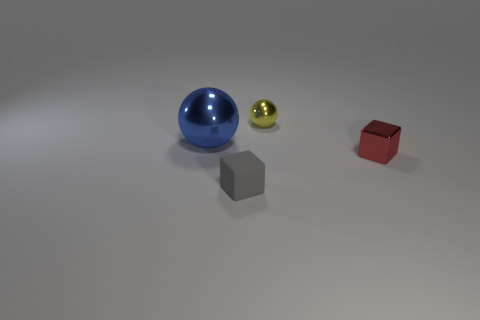Add 4 large metal spheres. How many objects exist? 8 Subtract all blue cubes. How many yellow balls are left? 1 Add 4 small red objects. How many small red objects are left? 5 Add 4 large purple metallic objects. How many large purple metallic objects exist? 4 Subtract 0 purple balls. How many objects are left? 4 Subtract 2 blocks. How many blocks are left? 0 Subtract all blue blocks. Subtract all cyan cylinders. How many blocks are left? 2 Subtract all tiny spheres. Subtract all big purple matte things. How many objects are left? 3 